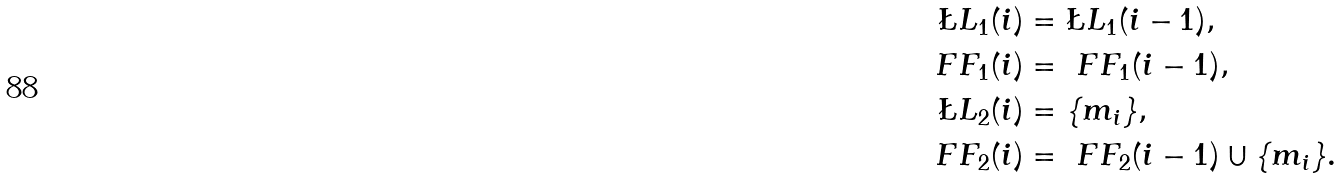<formula> <loc_0><loc_0><loc_500><loc_500>\L L _ { 1 } ( i ) & = \L L _ { 1 } ( i - 1 ) , \\ \ F F _ { 1 } ( i ) & = \ F F _ { 1 } ( i - 1 ) , \\ \L L _ { 2 } ( i ) & = \{ m _ { i } \} , \\ \ F F _ { 2 } ( i ) & = \ F F _ { 2 } ( i - 1 ) \cup \{ m _ { i } \} .</formula> 